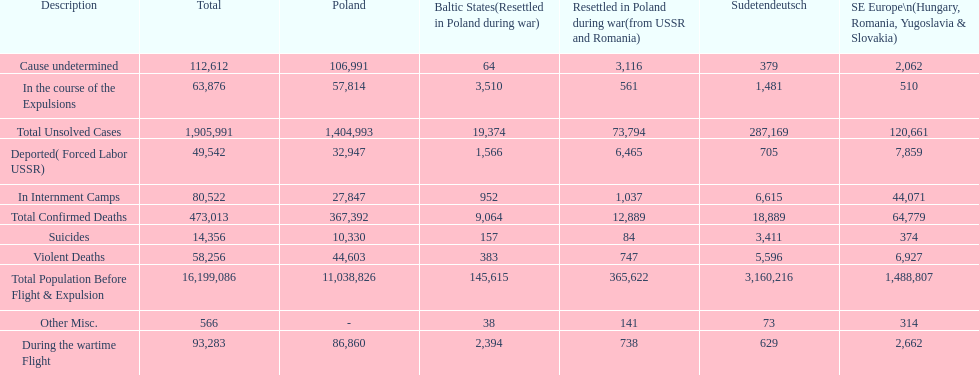Which region had the least total of unsolved cases? Baltic States(Resettled in Poland during war). 